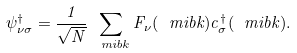Convert formula to latex. <formula><loc_0><loc_0><loc_500><loc_500>\psi _ { \nu \sigma } ^ { \dagger } = \frac { 1 } { \sqrt { N } } \sum _ { \ m i b { k } } F _ { \nu } ( \ m i b { k } ) c _ { \sigma } ^ { \dag } ( \ m i b { k } ) .</formula> 